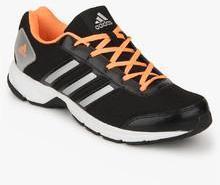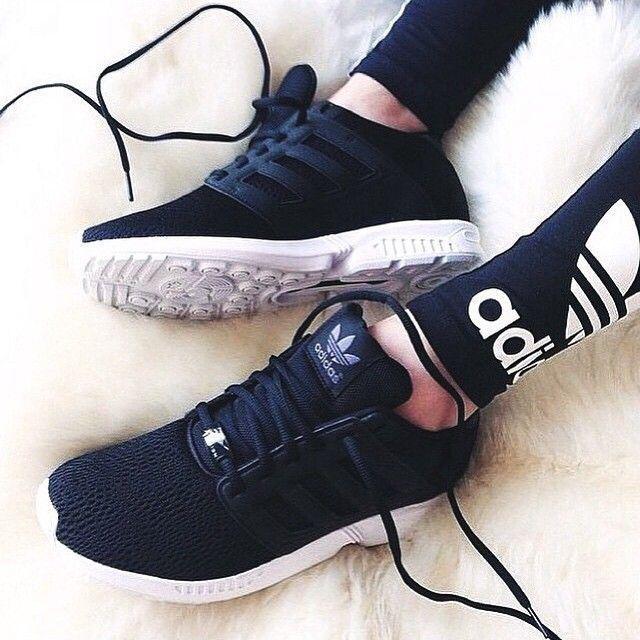The first image is the image on the left, the second image is the image on the right. Evaluate the accuracy of this statement regarding the images: "There is a part of a human visible on at least one of the images.". Is it true? Answer yes or no. Yes. 